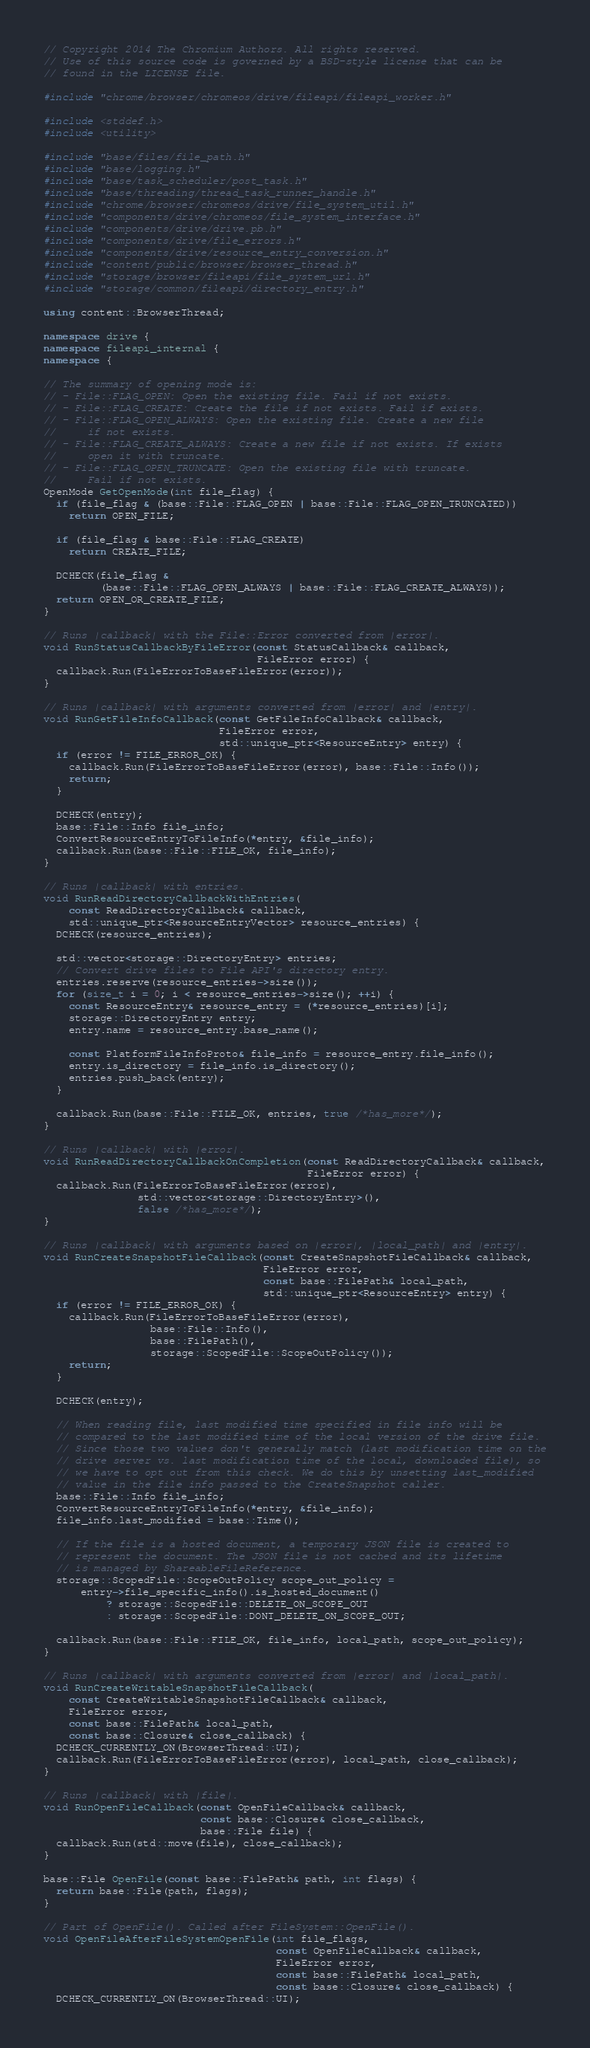<code> <loc_0><loc_0><loc_500><loc_500><_C++_>// Copyright 2014 The Chromium Authors. All rights reserved.
// Use of this source code is governed by a BSD-style license that can be
// found in the LICENSE file.

#include "chrome/browser/chromeos/drive/fileapi/fileapi_worker.h"

#include <stddef.h>
#include <utility>

#include "base/files/file_path.h"
#include "base/logging.h"
#include "base/task_scheduler/post_task.h"
#include "base/threading/thread_task_runner_handle.h"
#include "chrome/browser/chromeos/drive/file_system_util.h"
#include "components/drive/chromeos/file_system_interface.h"
#include "components/drive/drive.pb.h"
#include "components/drive/file_errors.h"
#include "components/drive/resource_entry_conversion.h"
#include "content/public/browser/browser_thread.h"
#include "storage/browser/fileapi/file_system_url.h"
#include "storage/common/fileapi/directory_entry.h"

using content::BrowserThread;

namespace drive {
namespace fileapi_internal {
namespace {

// The summary of opening mode is:
// - File::FLAG_OPEN: Open the existing file. Fail if not exists.
// - File::FLAG_CREATE: Create the file if not exists. Fail if exists.
// - File::FLAG_OPEN_ALWAYS: Open the existing file. Create a new file
//     if not exists.
// - File::FLAG_CREATE_ALWAYS: Create a new file if not exists. If exists
//     open it with truncate.
// - File::FLAG_OPEN_TRUNCATE: Open the existing file with truncate.
//     Fail if not exists.
OpenMode GetOpenMode(int file_flag) {
  if (file_flag & (base::File::FLAG_OPEN | base::File::FLAG_OPEN_TRUNCATED))
    return OPEN_FILE;

  if (file_flag & base::File::FLAG_CREATE)
    return CREATE_FILE;

  DCHECK(file_flag &
         (base::File::FLAG_OPEN_ALWAYS | base::File::FLAG_CREATE_ALWAYS));
  return OPEN_OR_CREATE_FILE;
}

// Runs |callback| with the File::Error converted from |error|.
void RunStatusCallbackByFileError(const StatusCallback& callback,
                                  FileError error) {
  callback.Run(FileErrorToBaseFileError(error));
}

// Runs |callback| with arguments converted from |error| and |entry|.
void RunGetFileInfoCallback(const GetFileInfoCallback& callback,
                            FileError error,
                            std::unique_ptr<ResourceEntry> entry) {
  if (error != FILE_ERROR_OK) {
    callback.Run(FileErrorToBaseFileError(error), base::File::Info());
    return;
  }

  DCHECK(entry);
  base::File::Info file_info;
  ConvertResourceEntryToFileInfo(*entry, &file_info);
  callback.Run(base::File::FILE_OK, file_info);
}

// Runs |callback| with entries.
void RunReadDirectoryCallbackWithEntries(
    const ReadDirectoryCallback& callback,
    std::unique_ptr<ResourceEntryVector> resource_entries) {
  DCHECK(resource_entries);

  std::vector<storage::DirectoryEntry> entries;
  // Convert drive files to File API's directory entry.
  entries.reserve(resource_entries->size());
  for (size_t i = 0; i < resource_entries->size(); ++i) {
    const ResourceEntry& resource_entry = (*resource_entries)[i];
    storage::DirectoryEntry entry;
    entry.name = resource_entry.base_name();

    const PlatformFileInfoProto& file_info = resource_entry.file_info();
    entry.is_directory = file_info.is_directory();
    entries.push_back(entry);
  }

  callback.Run(base::File::FILE_OK, entries, true /*has_more*/);
}

// Runs |callback| with |error|.
void RunReadDirectoryCallbackOnCompletion(const ReadDirectoryCallback& callback,
                                          FileError error) {
  callback.Run(FileErrorToBaseFileError(error),
               std::vector<storage::DirectoryEntry>(),
               false /*has_more*/);
}

// Runs |callback| with arguments based on |error|, |local_path| and |entry|.
void RunCreateSnapshotFileCallback(const CreateSnapshotFileCallback& callback,
                                   FileError error,
                                   const base::FilePath& local_path,
                                   std::unique_ptr<ResourceEntry> entry) {
  if (error != FILE_ERROR_OK) {
    callback.Run(FileErrorToBaseFileError(error),
                 base::File::Info(),
                 base::FilePath(),
                 storage::ScopedFile::ScopeOutPolicy());
    return;
  }

  DCHECK(entry);

  // When reading file, last modified time specified in file info will be
  // compared to the last modified time of the local version of the drive file.
  // Since those two values don't generally match (last modification time on the
  // drive server vs. last modification time of the local, downloaded file), so
  // we have to opt out from this check. We do this by unsetting last_modified
  // value in the file info passed to the CreateSnapshot caller.
  base::File::Info file_info;
  ConvertResourceEntryToFileInfo(*entry, &file_info);
  file_info.last_modified = base::Time();

  // If the file is a hosted document, a temporary JSON file is created to
  // represent the document. The JSON file is not cached and its lifetime
  // is managed by ShareableFileReference.
  storage::ScopedFile::ScopeOutPolicy scope_out_policy =
      entry->file_specific_info().is_hosted_document()
          ? storage::ScopedFile::DELETE_ON_SCOPE_OUT
          : storage::ScopedFile::DONT_DELETE_ON_SCOPE_OUT;

  callback.Run(base::File::FILE_OK, file_info, local_path, scope_out_policy);
}

// Runs |callback| with arguments converted from |error| and |local_path|.
void RunCreateWritableSnapshotFileCallback(
    const CreateWritableSnapshotFileCallback& callback,
    FileError error,
    const base::FilePath& local_path,
    const base::Closure& close_callback) {
  DCHECK_CURRENTLY_ON(BrowserThread::UI);
  callback.Run(FileErrorToBaseFileError(error), local_path, close_callback);
}

// Runs |callback| with |file|.
void RunOpenFileCallback(const OpenFileCallback& callback,
                         const base::Closure& close_callback,
                         base::File file) {
  callback.Run(std::move(file), close_callback);
}

base::File OpenFile(const base::FilePath& path, int flags) {
  return base::File(path, flags);
}

// Part of OpenFile(). Called after FileSystem::OpenFile().
void OpenFileAfterFileSystemOpenFile(int file_flags,
                                     const OpenFileCallback& callback,
                                     FileError error,
                                     const base::FilePath& local_path,
                                     const base::Closure& close_callback) {
  DCHECK_CURRENTLY_ON(BrowserThread::UI);
</code> 